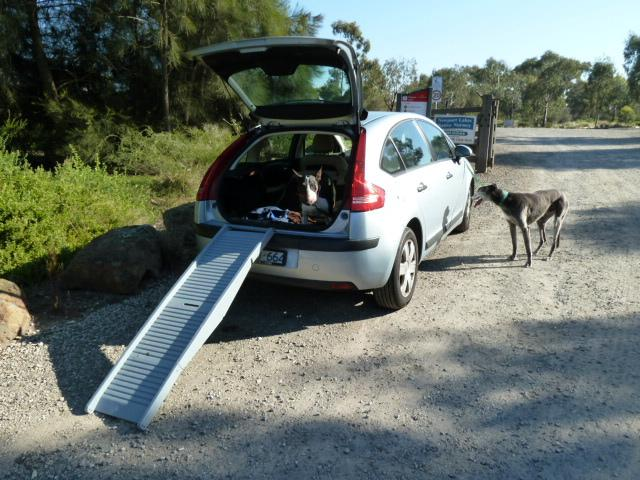What uses the ramp on the back of the car?

Choices:
A) birds
B) cats
C) babies
D) dogs dogs 